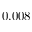<formula> <loc_0><loc_0><loc_500><loc_500>0 . 0 0 8</formula> 